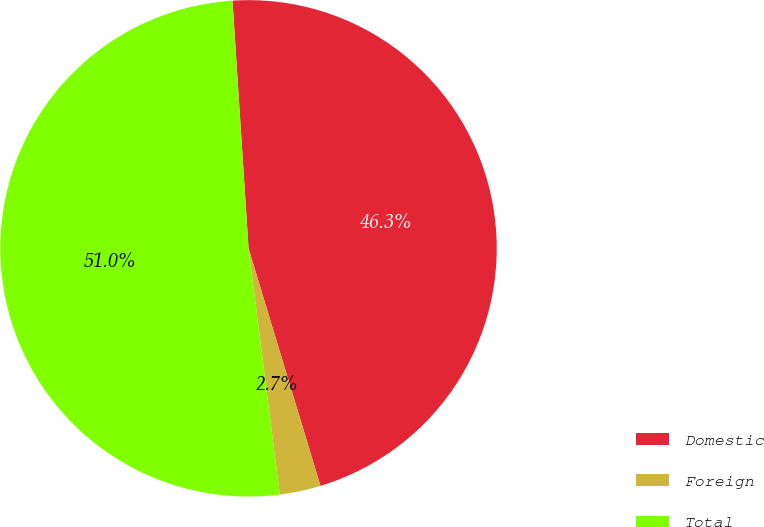Convert chart. <chart><loc_0><loc_0><loc_500><loc_500><pie_chart><fcel>Domestic<fcel>Foreign<fcel>Total<nl><fcel>46.35%<fcel>2.67%<fcel>50.98%<nl></chart> 